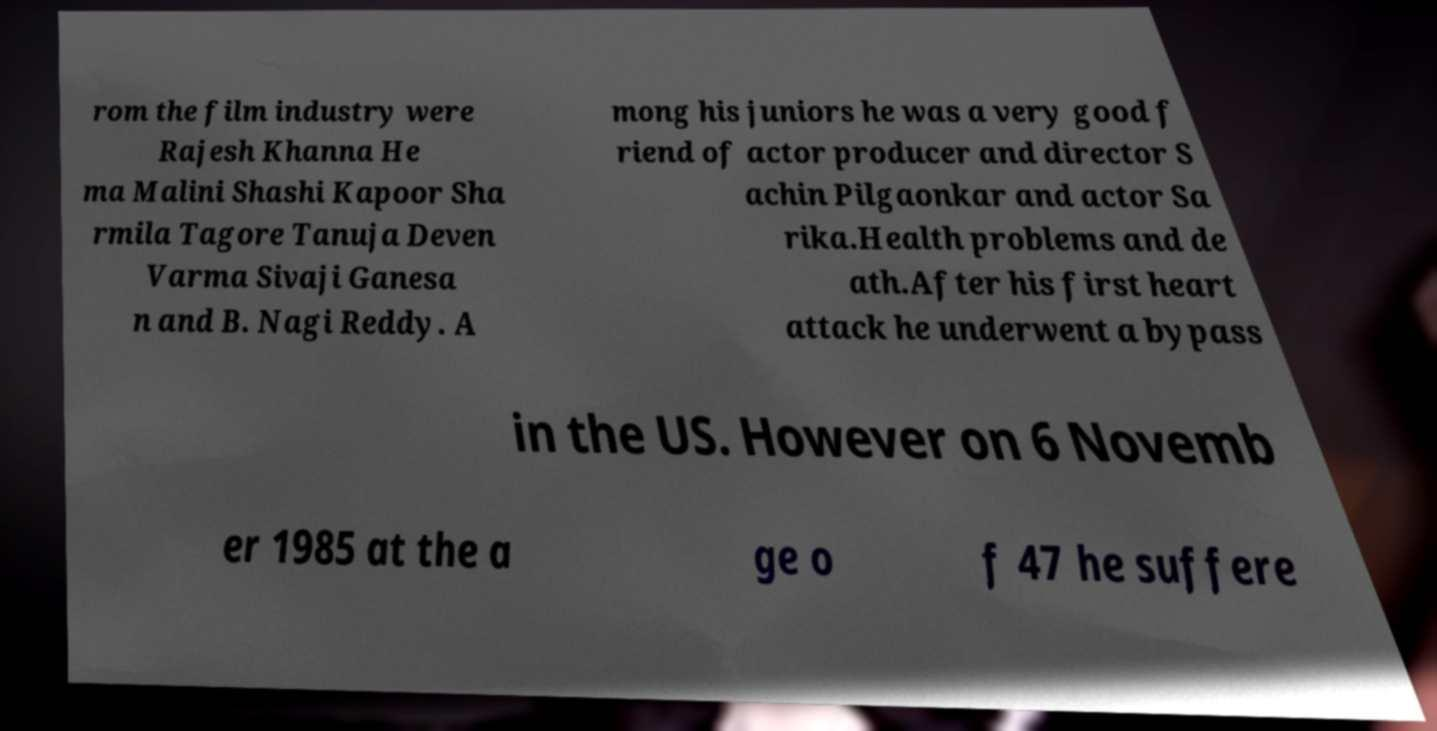For documentation purposes, I need the text within this image transcribed. Could you provide that? rom the film industry were Rajesh Khanna He ma Malini Shashi Kapoor Sha rmila Tagore Tanuja Deven Varma Sivaji Ganesa n and B. Nagi Reddy. A mong his juniors he was a very good f riend of actor producer and director S achin Pilgaonkar and actor Sa rika.Health problems and de ath.After his first heart attack he underwent a bypass in the US. However on 6 Novemb er 1985 at the a ge o f 47 he suffere 